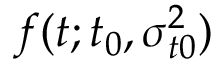Convert formula to latex. <formula><loc_0><loc_0><loc_500><loc_500>f ( t ; t _ { 0 } , \sigma _ { t 0 } ^ { 2 } )</formula> 